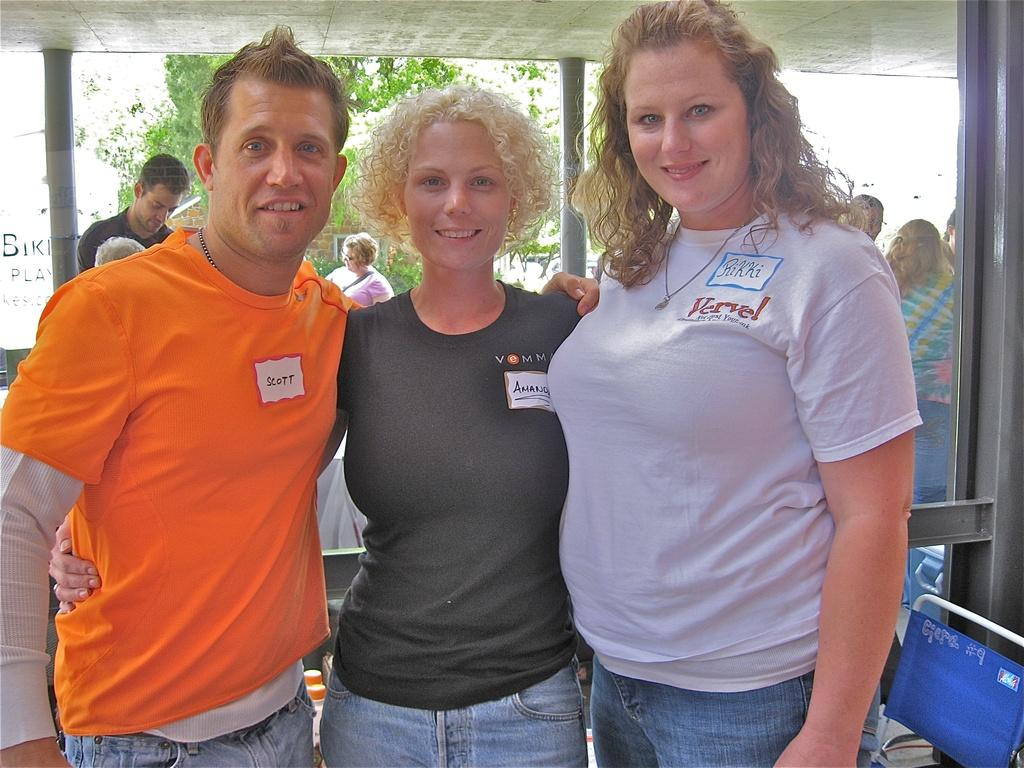How many people are standing in the image? There are three persons standing in the image. What else can be seen in the image besides the people? There is a chair and pillars in the image. What is visible in the background of the image? There are trees in the background of the image. Can you describe the group of people in the image? There is a group of people standing in the image, which includes the three persons mentioned earlier. What type of animal is the maid talking to in the image? There is no animal or maid present in the image. What are the three persons talking about in the image? The conversation does not mention what the three persons are talking about, as the focus is on describing the objects and features visible in the image. 